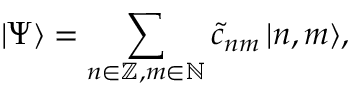Convert formula to latex. <formula><loc_0><loc_0><loc_500><loc_500>| \Psi \rangle = \sum _ { n \in \mathbb { Z } , m \in \mathbb { N } } \tilde { c } _ { n m } \, | n , m \rangle ,</formula> 